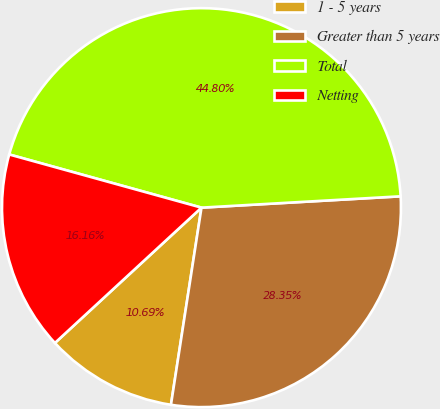Convert chart. <chart><loc_0><loc_0><loc_500><loc_500><pie_chart><fcel>1 - 5 years<fcel>Greater than 5 years<fcel>Total<fcel>Netting<nl><fcel>10.69%<fcel>28.35%<fcel>44.8%<fcel>16.16%<nl></chart> 